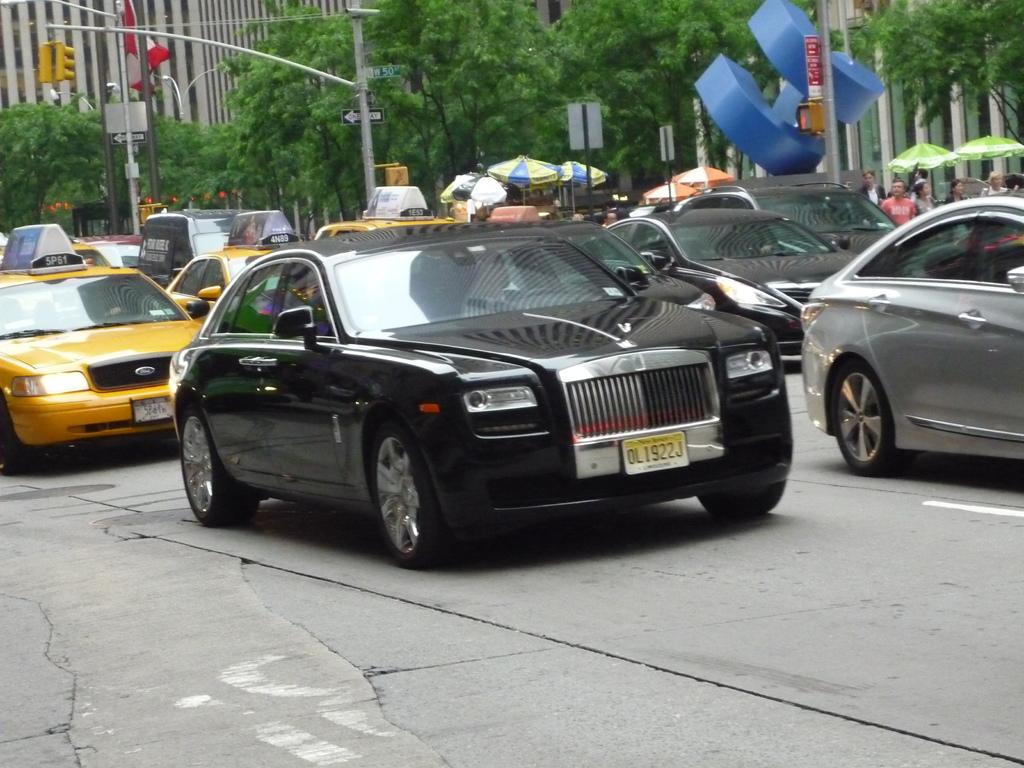What is the license plate number?
Give a very brief answer. Ol1922j. 